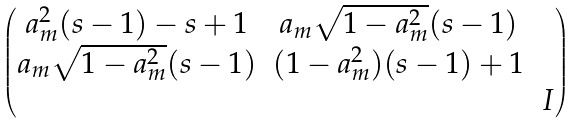Convert formula to latex. <formula><loc_0><loc_0><loc_500><loc_500>\begin{pmatrix} a ^ { 2 } _ { m } ( s - 1 ) - s + 1 & a _ { m } \sqrt { 1 - a ^ { 2 } _ { m } } ( s - 1 ) \\ a _ { m } \sqrt { 1 - a ^ { 2 } _ { m } } ( s - 1 ) & ( 1 - a ^ { 2 } _ { m } ) ( s - 1 ) + 1 \\ & & I \\ \end{pmatrix}</formula> 